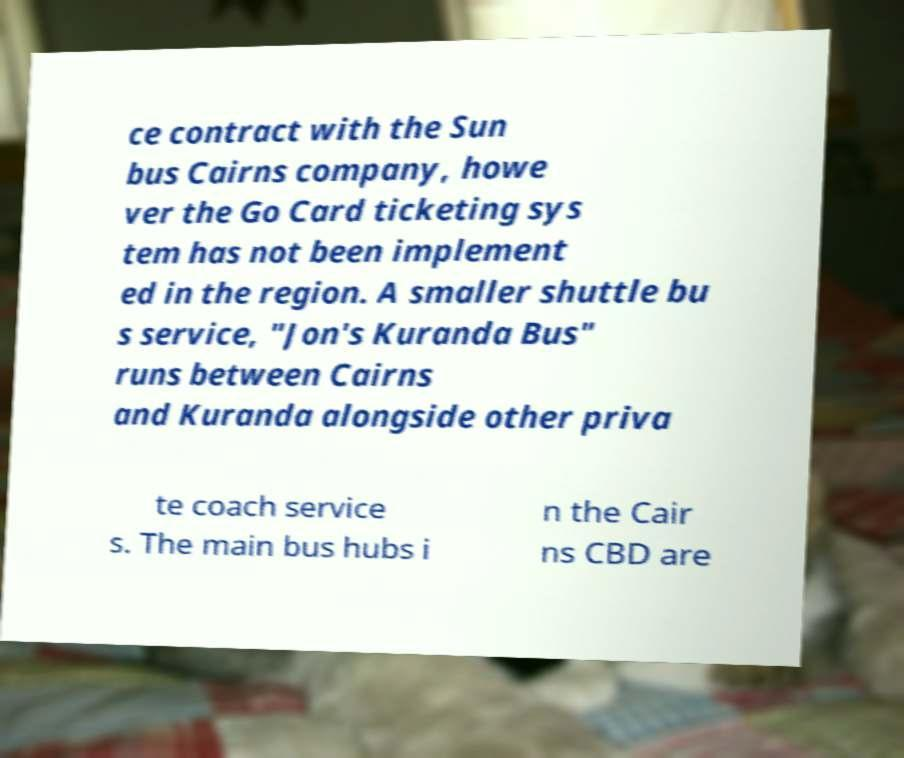For documentation purposes, I need the text within this image transcribed. Could you provide that? ce contract with the Sun bus Cairns company, howe ver the Go Card ticketing sys tem has not been implement ed in the region. A smaller shuttle bu s service, "Jon's Kuranda Bus" runs between Cairns and Kuranda alongside other priva te coach service s. The main bus hubs i n the Cair ns CBD are 